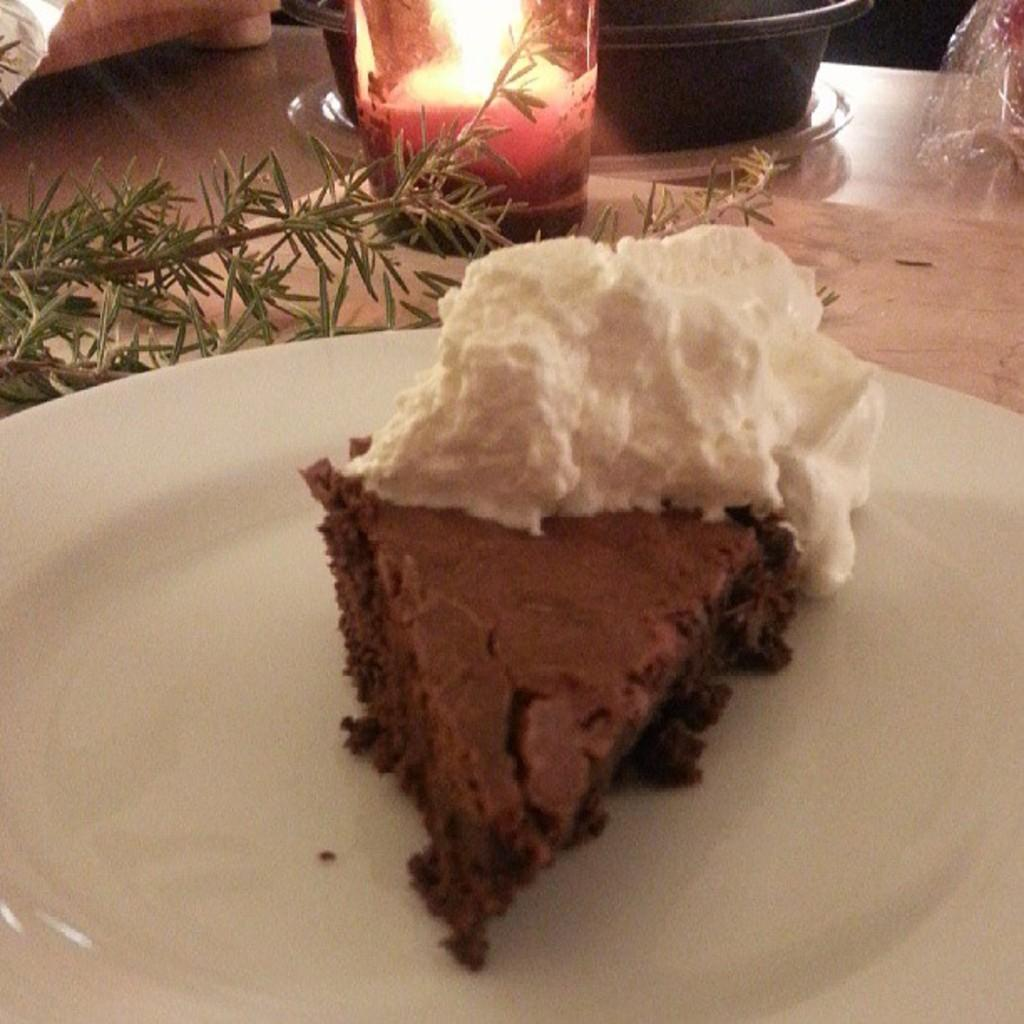What type of dessert is featured in the image? There is a cake with cream in the image. What is the candle's condition in the image? There is a candle with a flame in a glass in the image. What type of plant is present in the image? There is a plant in the image. What is on the table in the image? There are objects on the table in the image. How would you describe the lighting in the image? The background of the image is dark. What type of shelf can be seen in the image? There is no shelf present in the image. What shape is the cake in the image? The shape of the cake is not mentioned in the provided facts, so it cannot be determined from the image. 